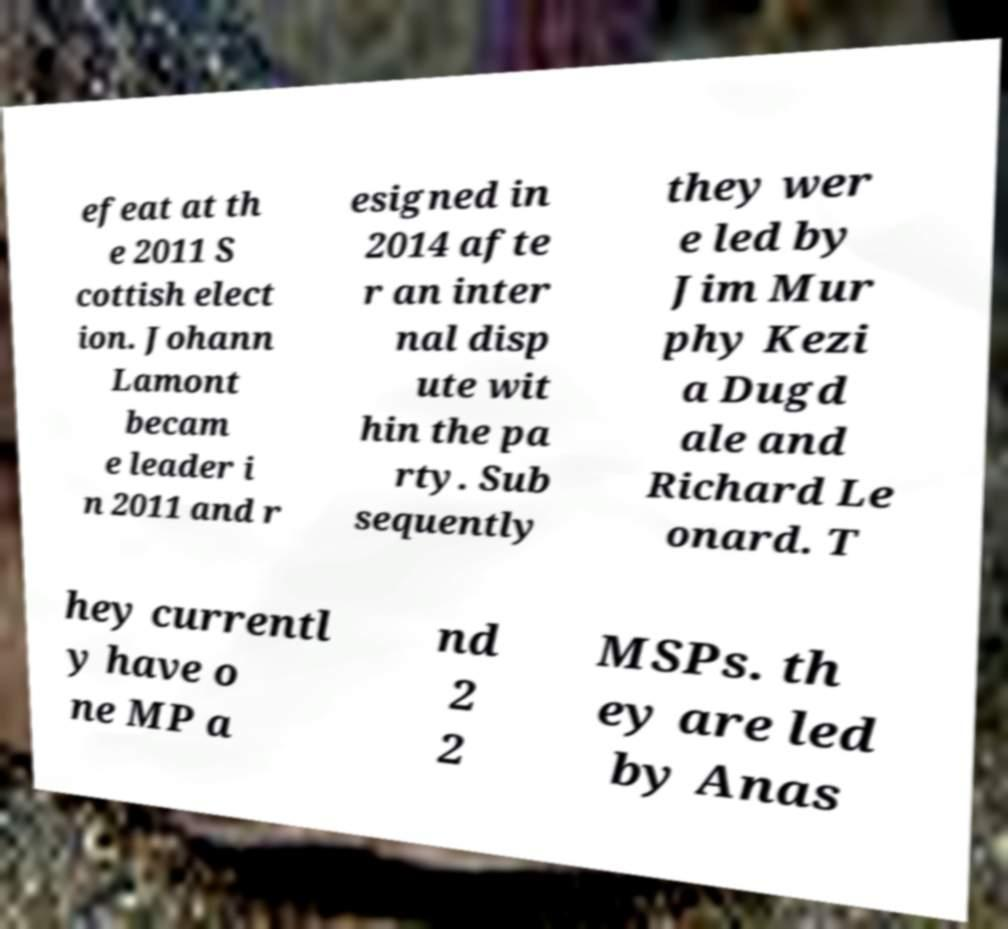Please identify and transcribe the text found in this image. efeat at th e 2011 S cottish elect ion. Johann Lamont becam e leader i n 2011 and r esigned in 2014 afte r an inter nal disp ute wit hin the pa rty. Sub sequently they wer e led by Jim Mur phy Kezi a Dugd ale and Richard Le onard. T hey currentl y have o ne MP a nd 2 2 MSPs. th ey are led by Anas 